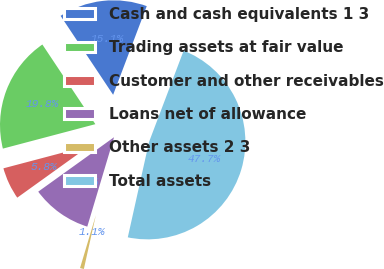<chart> <loc_0><loc_0><loc_500><loc_500><pie_chart><fcel>Cash and cash equivalents 1 3<fcel>Trading assets at fair value<fcel>Customer and other receivables<fcel>Loans net of allowance<fcel>Other assets 2 3<fcel>Total assets<nl><fcel>15.11%<fcel>19.77%<fcel>5.8%<fcel>10.46%<fcel>1.14%<fcel>47.72%<nl></chart> 